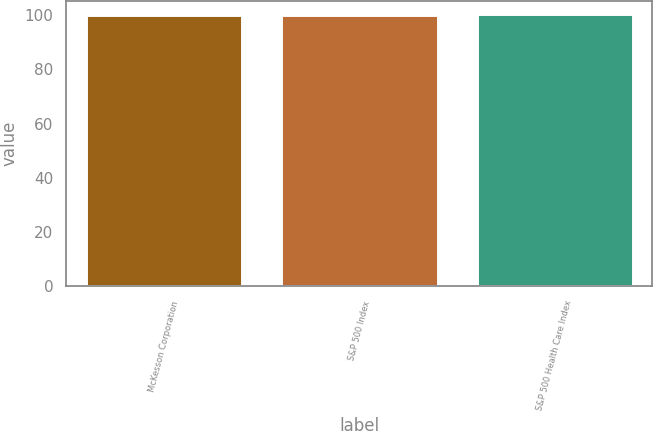Convert chart to OTSL. <chart><loc_0><loc_0><loc_500><loc_500><bar_chart><fcel>McKesson Corporation<fcel>S&P 500 Index<fcel>S&P 500 Health Care Index<nl><fcel>100<fcel>100.1<fcel>100.2<nl></chart> 